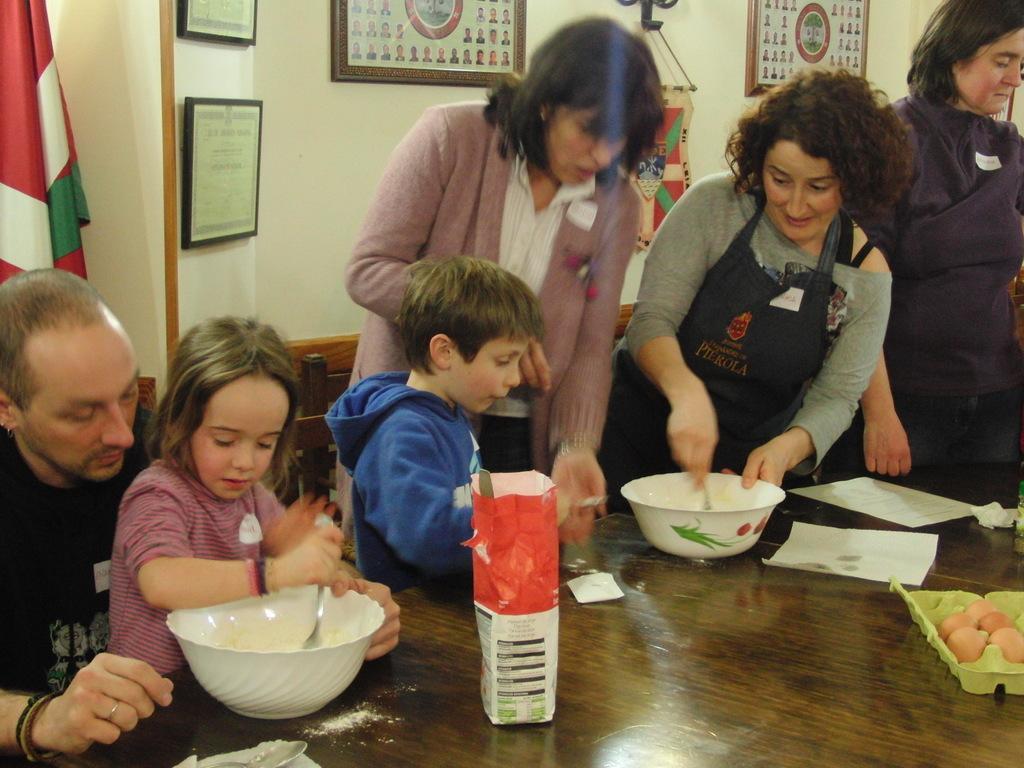Can you describe this image briefly? In the center of the image there are persons at the table. On the table we can see bowls, spoons, papers and eggs. In the background we can see photo frames, flag and wall. 